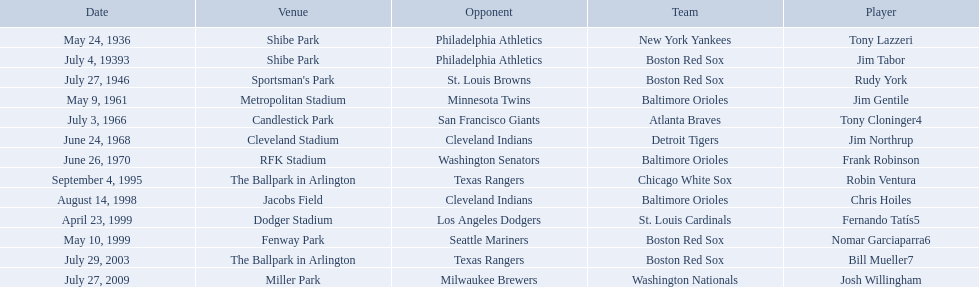Who are the opponents of the boston red sox during baseball home run records? Philadelphia Athletics, St. Louis Browns, Seattle Mariners, Texas Rangers. Of those which was the opponent on july 27, 1946? St. Louis Browns. Which teams played between the years 1960 and 1970? Baltimore Orioles, Atlanta Braves, Detroit Tigers, Baltimore Orioles. Of these teams that played, which ones played against the cleveland indians? Detroit Tigers. On what day did these two teams play? June 24, 1968. 